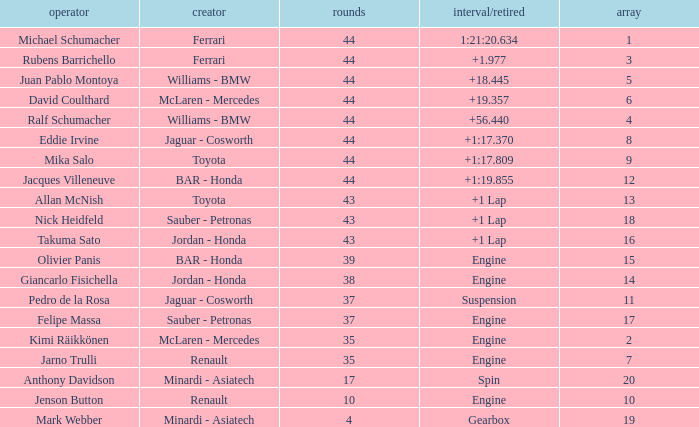What was the fewest laps for somone who finished +18.445? 44.0. 